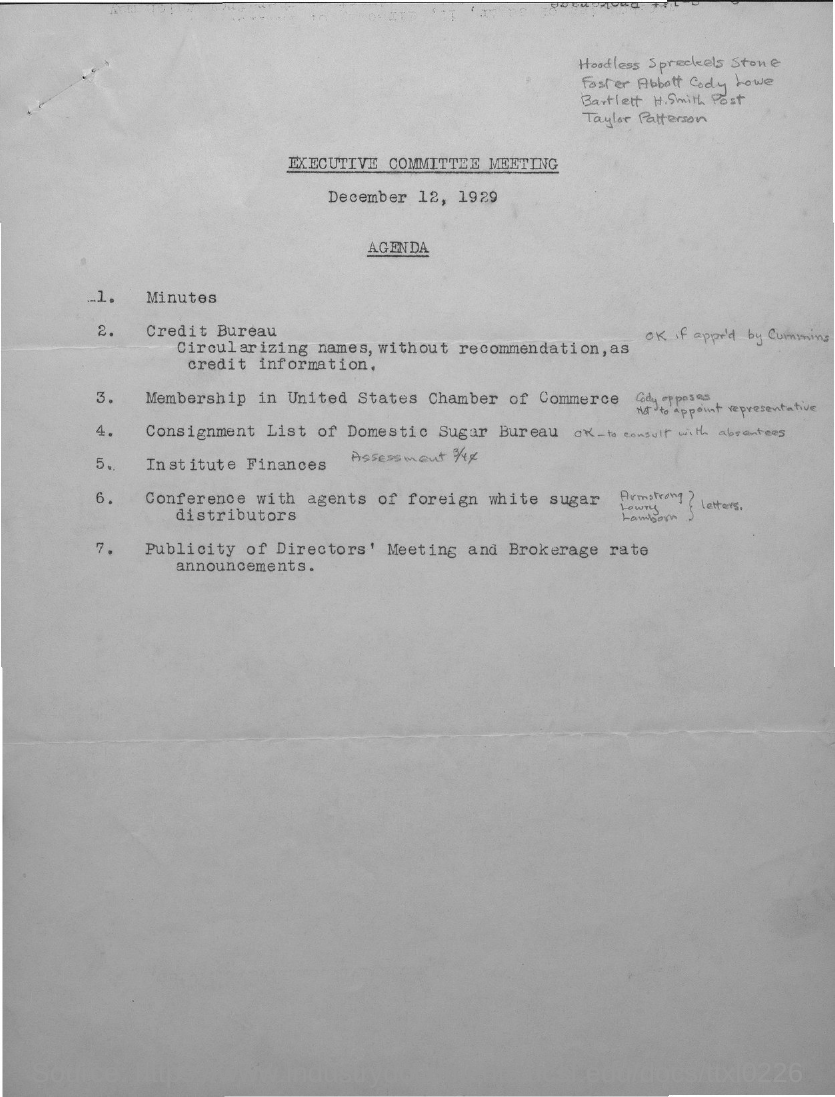Highlight a few significant elements in this photo. The executive committee meeting was held on December 12, 1929. 